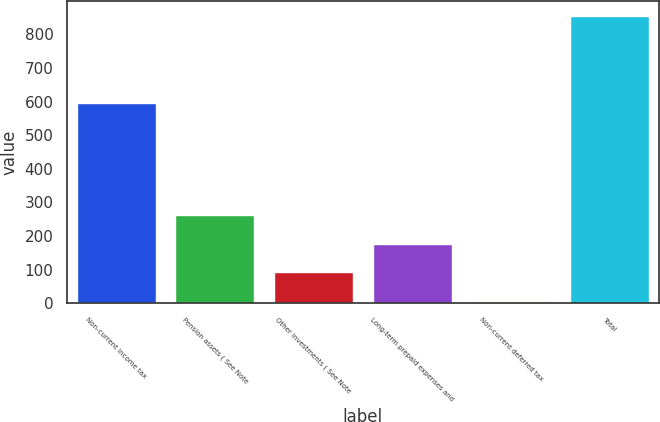Convert chart to OTSL. <chart><loc_0><loc_0><loc_500><loc_500><bar_chart><fcel>Non-current income tax<fcel>Pension assets ( See Note<fcel>Other investments ( See Note<fcel>Long-term prepaid expenses and<fcel>Non-current deferred tax<fcel>Total<nl><fcel>597<fcel>262.1<fcel>92.7<fcel>177.4<fcel>8<fcel>855<nl></chart> 